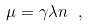<formula> <loc_0><loc_0><loc_500><loc_500>\mu = \gamma \lambda n \ ,</formula> 